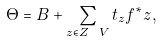<formula> <loc_0><loc_0><loc_500><loc_500>\Theta = B + \sum _ { z \in Z \ V } t _ { z } f ^ { * } z ,</formula> 